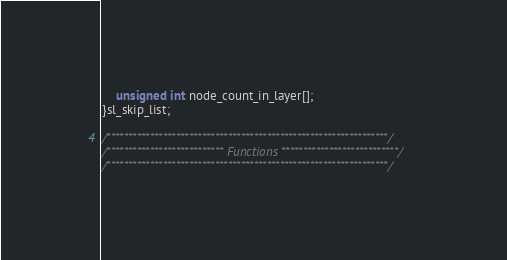Convert code to text. <code><loc_0><loc_0><loc_500><loc_500><_C_>	unsigned int node_count_in_layer[];
}sl_skip_list;

/*****************************************************************/
/*************************** Functions ***************************/
/*****************************************************************/
</code> 